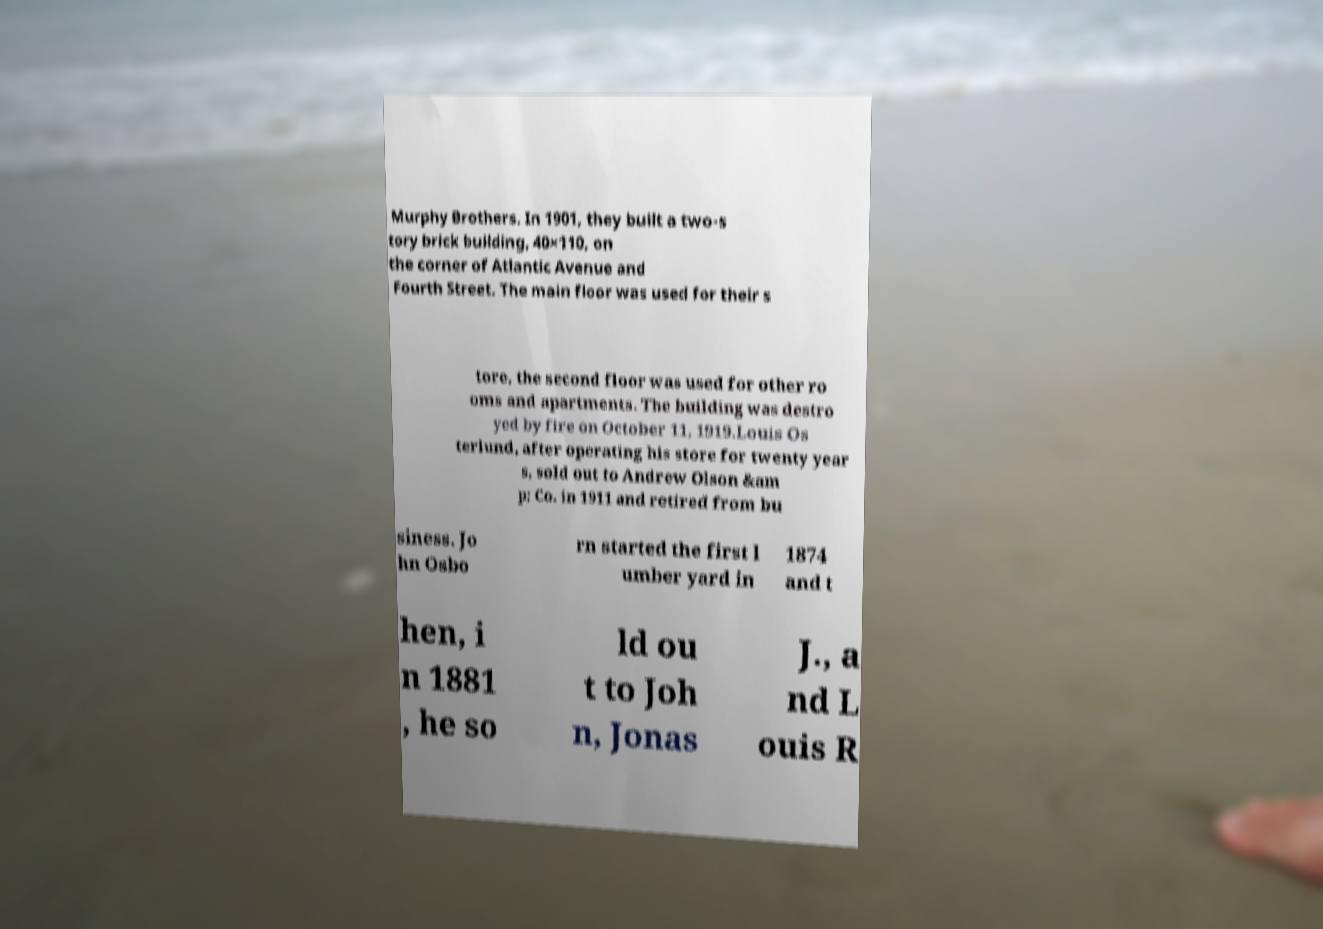Could you extract and type out the text from this image? Murphy Brothers. In 1901, they built a two-s tory brick building, 40×110, on the corner of Atlantic Avenue and Fourth Street. The main floor was used for their s tore, the second floor was used for other ro oms and apartments. The building was destro yed by fire on October 11, 1919.Louis Os terlund, after operating his store for twenty year s, sold out to Andrew Olson &am p; Co. in 1911 and retired from bu siness. Jo hn Osbo rn started the first l umber yard in 1874 and t hen, i n 1881 , he so ld ou t to Joh n, Jonas J., a nd L ouis R 